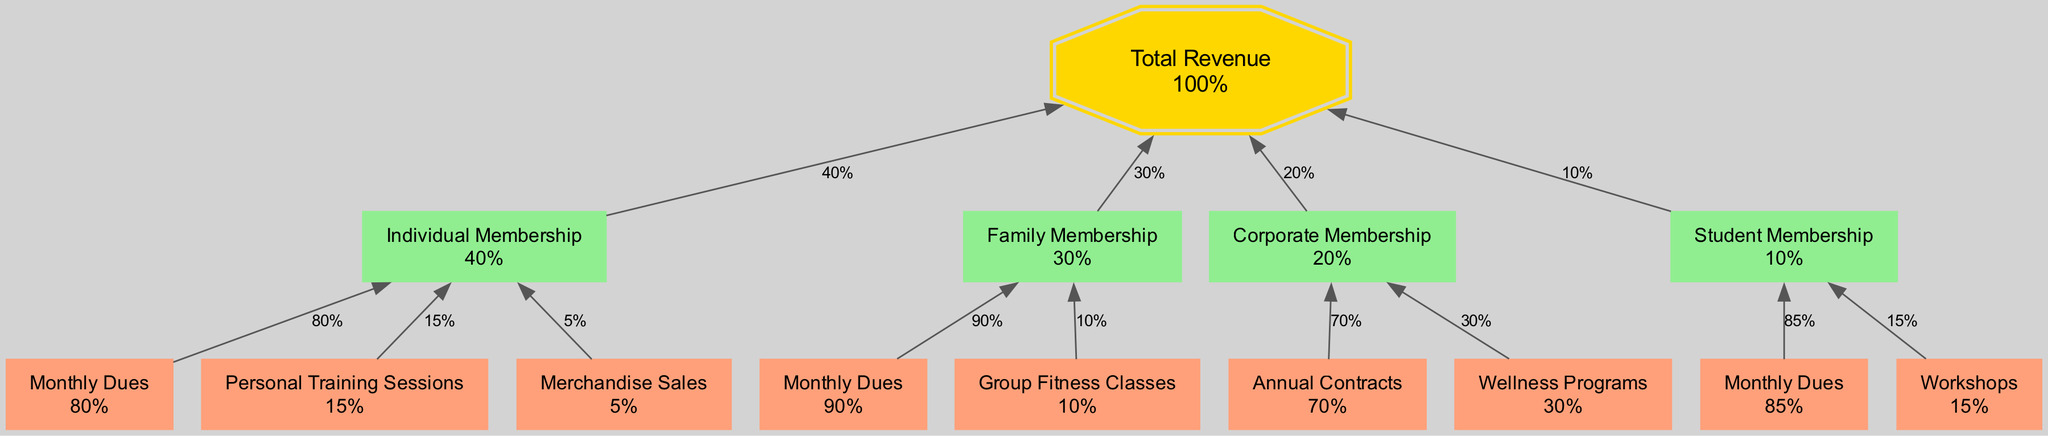What percentage of total revenue comes from Individual Membership? The Individual Membership contributes 40% to the Total Revenue as indicated in the diagram.
Answer: 40% How many income sources contribute to Family Membership? The diagram shows that there are two income sources for Family Membership: Monthly Dues and Group Fitness Classes.
Answer: 2 What is the source of income that contributes the most for Student Membership? For Student Membership, Monthly Dues contributes the most at 85%, as shown in the percentage next to the income source.
Answer: Monthly Dues Which membership type has the lowest percentage contribution to total revenue? The Student Membership contributes the least at 10%, which is the lowest percentage depicted in the diagram.
Answer: Student Membership What is the percentage contribution of Corporate Membership to total revenue? Corporate Membership contributes 20% to the Total Revenue, as labeled in the diagram.
Answer: 20% Which income source contributes the least for Individual Membership? Merchandise Sales contributes the least at 5%, as indicated by the percentage next to this source in the diagram.
Answer: Merchandise Sales How does the contribution from Family Membership compare to that of Individual Membership? Family Membership contributes 30%, which is 10% less than Individual Membership's contribution of 40%, showing the relationship between their percentages in the diagram.
Answer: 10% less What is the sum of the percentages of all income sources under Corporate Membership? The income sources under Corporate Membership, Annual Contracts (70%) and Wellness Programs (30%), total to 100%, which can be calculated by simply adding these two percentages together.
Answer: 100% 